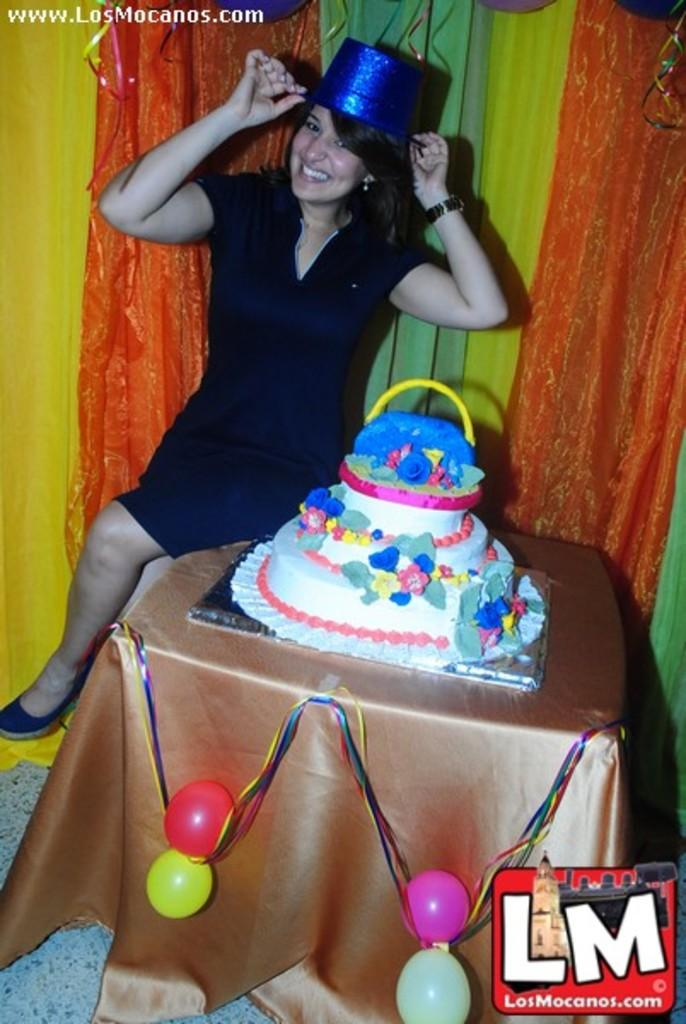Who is present in the image? There is a woman in the image. What is the woman doing? The woman is smiling. What is the woman wearing on her head? The woman is wearing a hat. What is on the table in the image? There is a cake on a table in the image. What type of fabric is present in the image? There is a cloth in the image. What decorative items can be seen in the image? There are balloons in the image. What type of window treatment is visible in the image? There are curtains in the image. What type of hole can be seen in the image? There is no hole present in the image. What is the source of the mist in the image? There is no mist present in the image. 